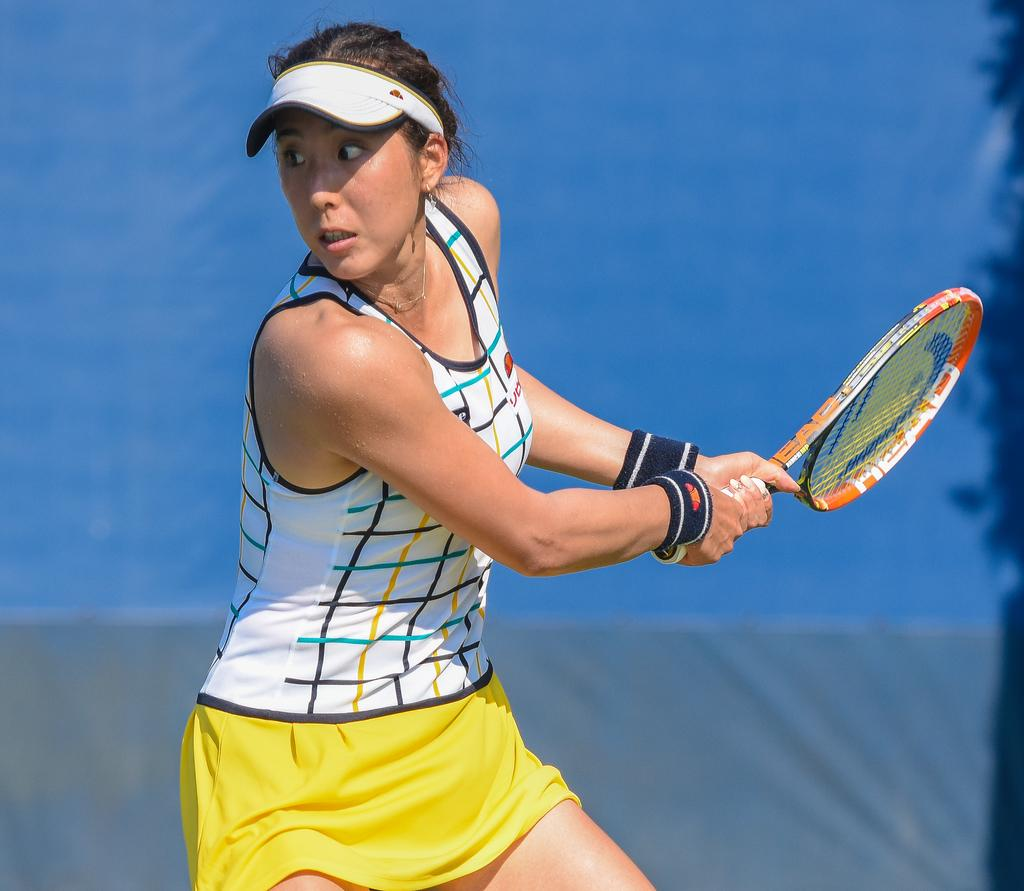What is the main subject of the image? The main subject of the image is a woman. What is the woman holding in her hand? The woman is holding a racket with her hand. What type of owl can be seen sitting on the pig in the image? There is no owl or pig present in the image; it features a woman holding a racket. 